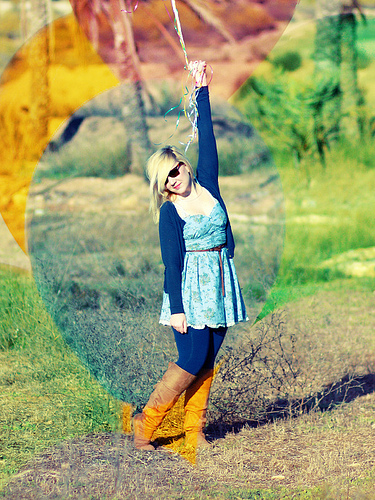<image>
Is there a string in the glasses? No. The string is not contained within the glasses. These objects have a different spatial relationship. 